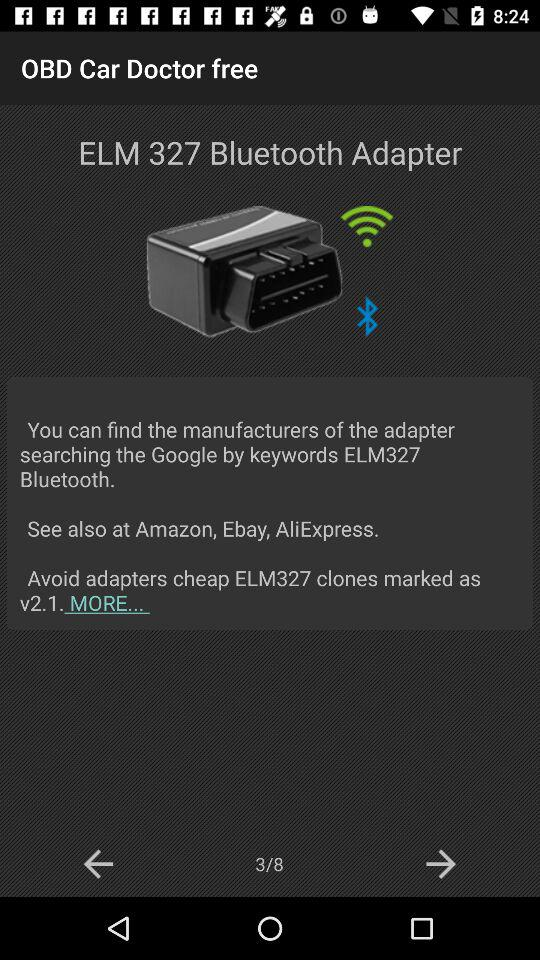Which adapters are to be avoided? The adapter to be avoided is "ELM327". 